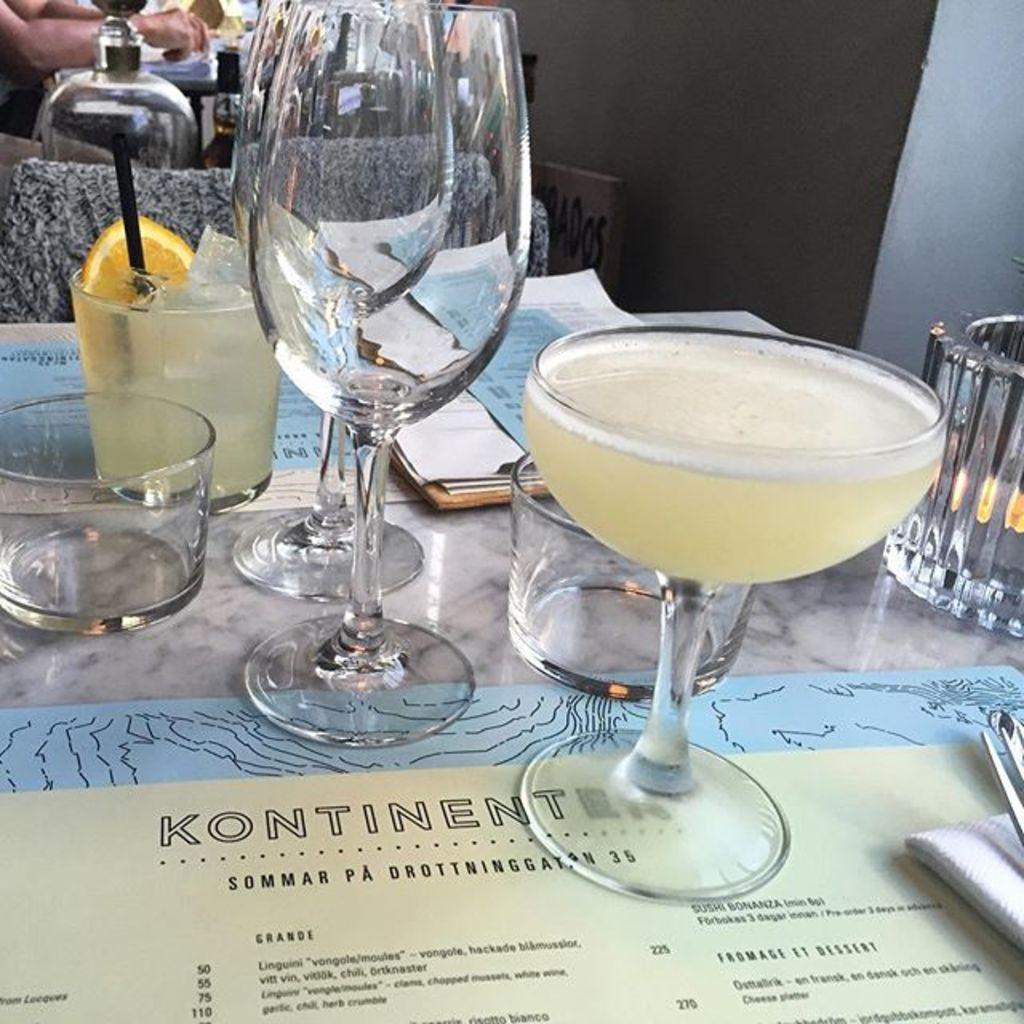Can you describe this image briefly? In this image i can see a few glasses and other objects. 